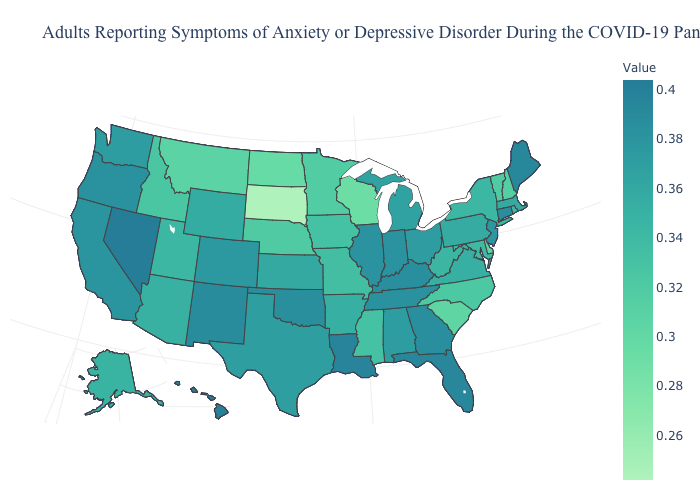Does South Dakota have the lowest value in the USA?
Answer briefly. Yes. Which states hav the highest value in the Northeast?
Give a very brief answer. Maine. Is the legend a continuous bar?
Quick response, please. Yes. Which states have the highest value in the USA?
Give a very brief answer. Nevada. 